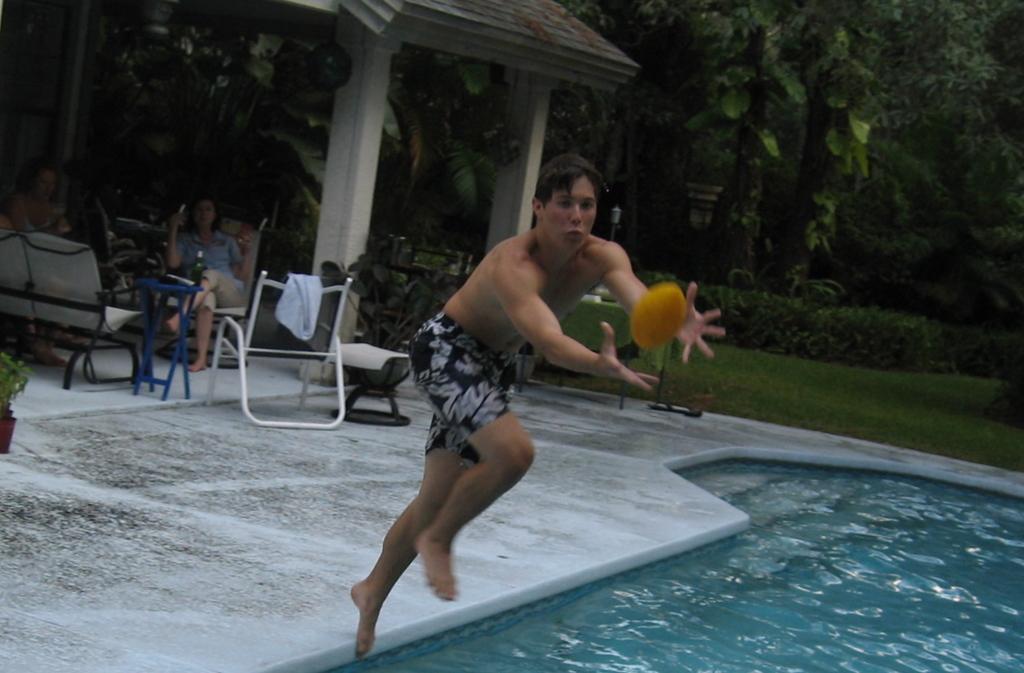Please provide a concise description of this image. The man in the middle of the picture is trying to catch the yellow color ball. At the bottom, we see the water in the swimming pool. Behind him, we see two women are sitting on the chairs and we even see the empty chairs and a white towel. Beside them, we see flower pots and pillars. There are trees, grass and shrubs in the background. 